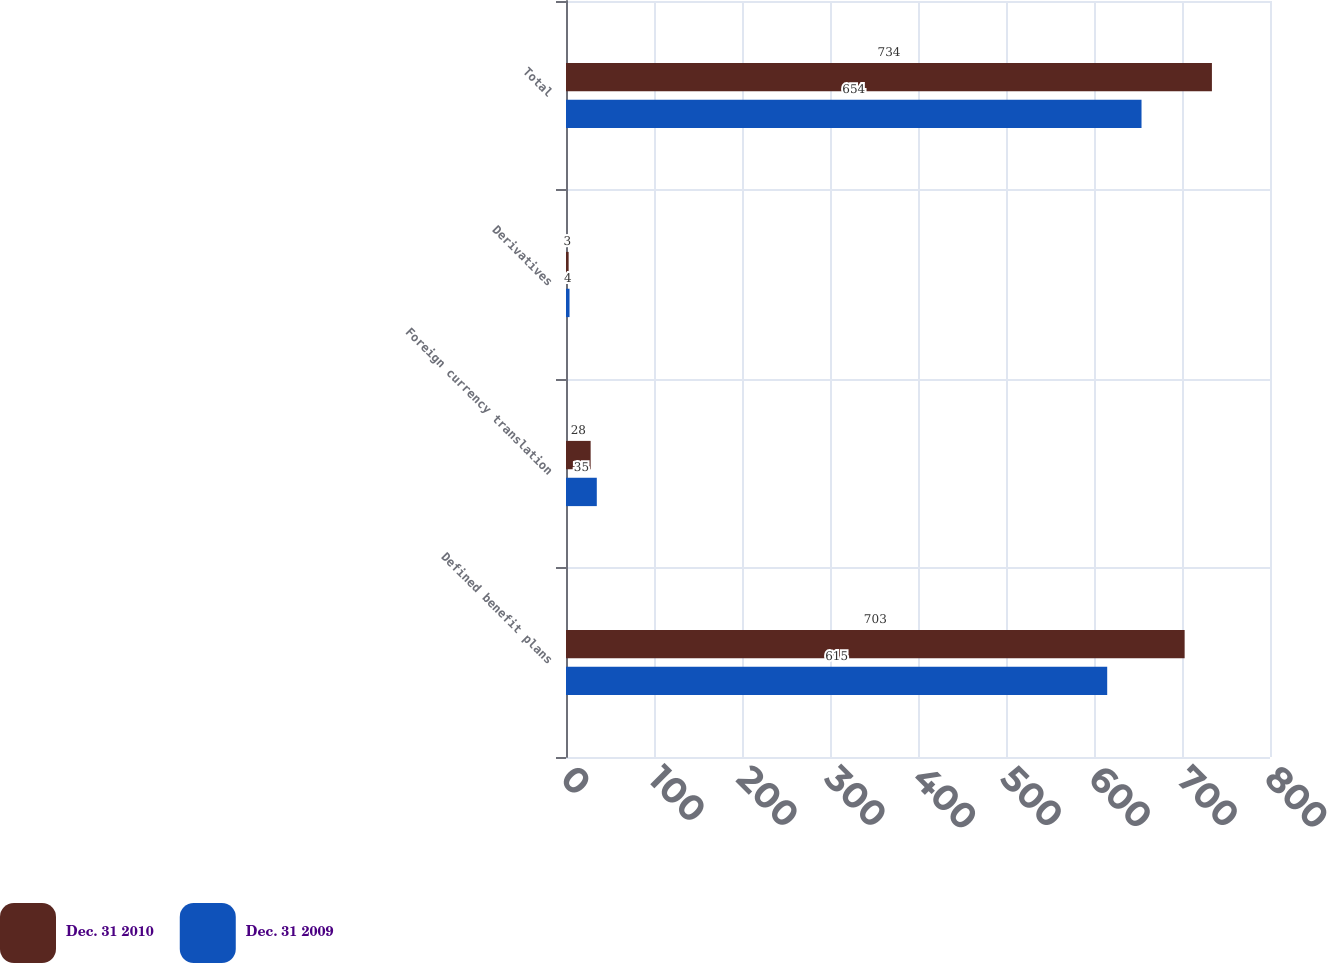<chart> <loc_0><loc_0><loc_500><loc_500><stacked_bar_chart><ecel><fcel>Defined benefit plans<fcel>Foreign currency translation<fcel>Derivatives<fcel>Total<nl><fcel>Dec. 31 2010<fcel>703<fcel>28<fcel>3<fcel>734<nl><fcel>Dec. 31 2009<fcel>615<fcel>35<fcel>4<fcel>654<nl></chart> 